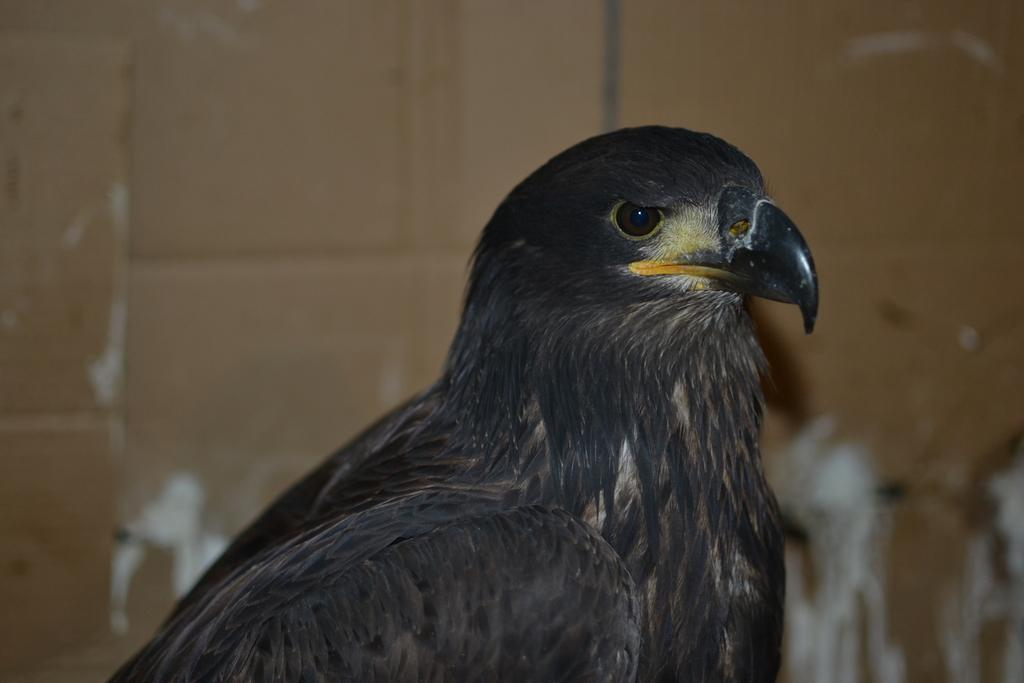What type of bird is in the image? There is an eagle in the image. What structure is visible in the image? There is a wall in the image. What type of fruit is the eagle holding in its talons in the image? There is no fruit present in the image, and the eagle is not holding anything in its talons. What riddle is the eagle trying to solve in the image? There is no riddle present in the image; it simply features an eagle and a wall. 